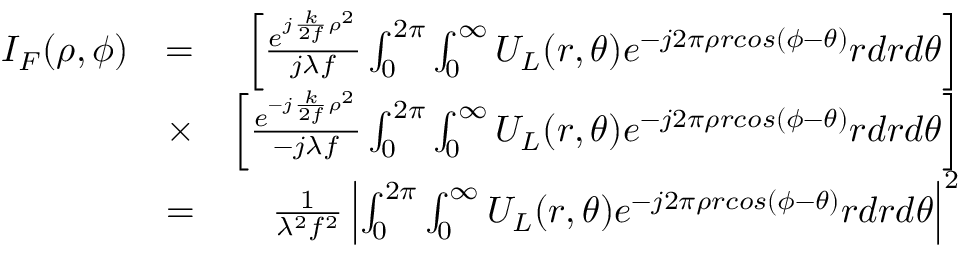Convert formula to latex. <formula><loc_0><loc_0><loc_500><loc_500>\begin{array} { r l r } { I _ { F } ( \rho , \phi ) } & { = } & { \left [ \frac { e ^ { j \frac { k } { 2 f } \rho ^ { 2 } } } { j \lambda f } \int _ { 0 } ^ { 2 \pi } \int _ { 0 } ^ { \infty } U _ { L } ( r , \theta ) e ^ { - j 2 \pi \rho r \cos ( \phi - \theta ) } r d r d \theta \right ] } \\ & { \times } & { \left [ \frac { e ^ { - j \frac { k } { 2 f } \rho ^ { 2 } } } { - j \lambda f } \int _ { 0 } ^ { 2 \pi } \int _ { 0 } ^ { \infty } U _ { L } ( r , \theta ) e ^ { - j 2 \pi \rho r \cos ( \phi - \theta ) } r d r d \theta \right ] } \\ & { = } & { \frac { 1 } { \lambda ^ { 2 } f ^ { 2 } } \left | \int _ { 0 } ^ { 2 \pi } \int _ { 0 } ^ { \infty } U _ { L } ( r , \theta ) e ^ { - j 2 \pi \rho r \cos ( \phi - \theta ) } r d r d \theta \right | ^ { 2 } } \end{array}</formula> 